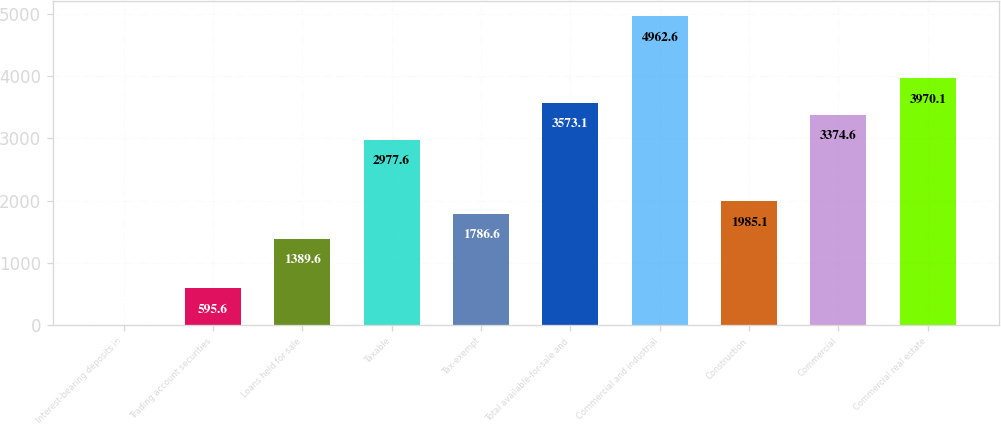Convert chart. <chart><loc_0><loc_0><loc_500><loc_500><bar_chart><fcel>Interest-bearing deposits in<fcel>Trading account securities<fcel>Loans held for sale<fcel>Taxable<fcel>Tax-exempt<fcel>Total available-for-sale and<fcel>Commercial and industrial<fcel>Construction<fcel>Commercial<fcel>Commercial real estate<nl><fcel>0.1<fcel>595.6<fcel>1389.6<fcel>2977.6<fcel>1786.6<fcel>3573.1<fcel>4962.6<fcel>1985.1<fcel>3374.6<fcel>3970.1<nl></chart> 